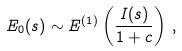<formula> <loc_0><loc_0><loc_500><loc_500>E _ { 0 } ( s ) \sim E ^ { ( 1 ) } \left ( \frac { I ( s ) } { 1 + c } \right ) \, ,</formula> 